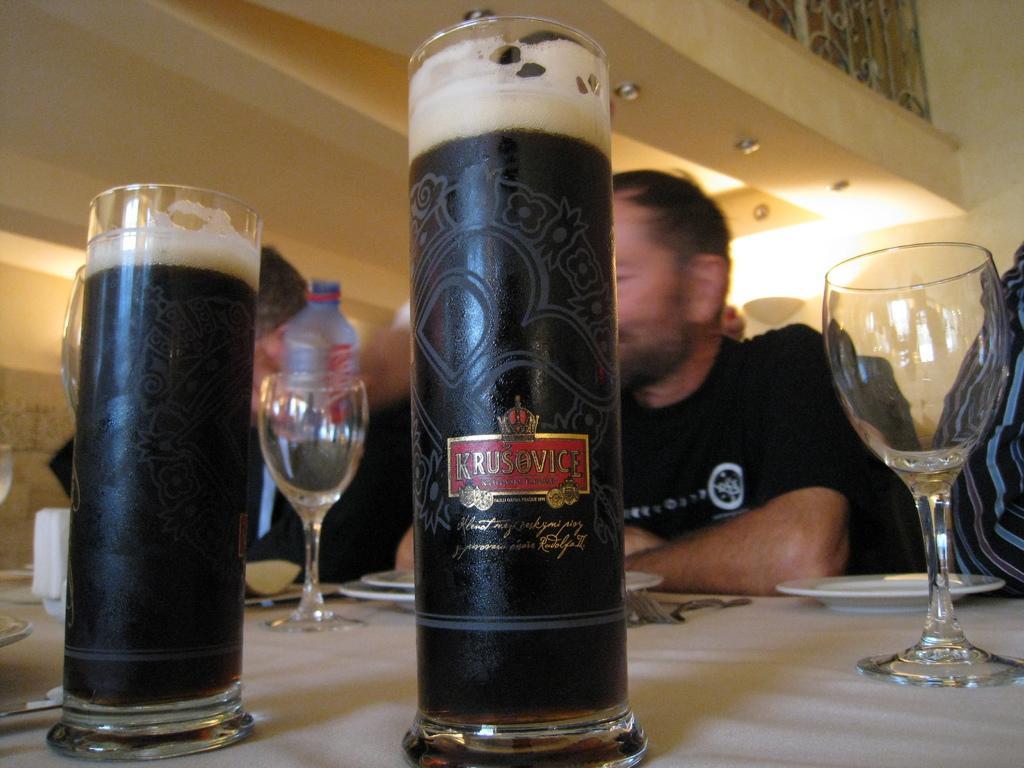In one or two sentences, can you explain what this image depicts? In this image I can see few glasses and few people. On this table I can see few plates. 